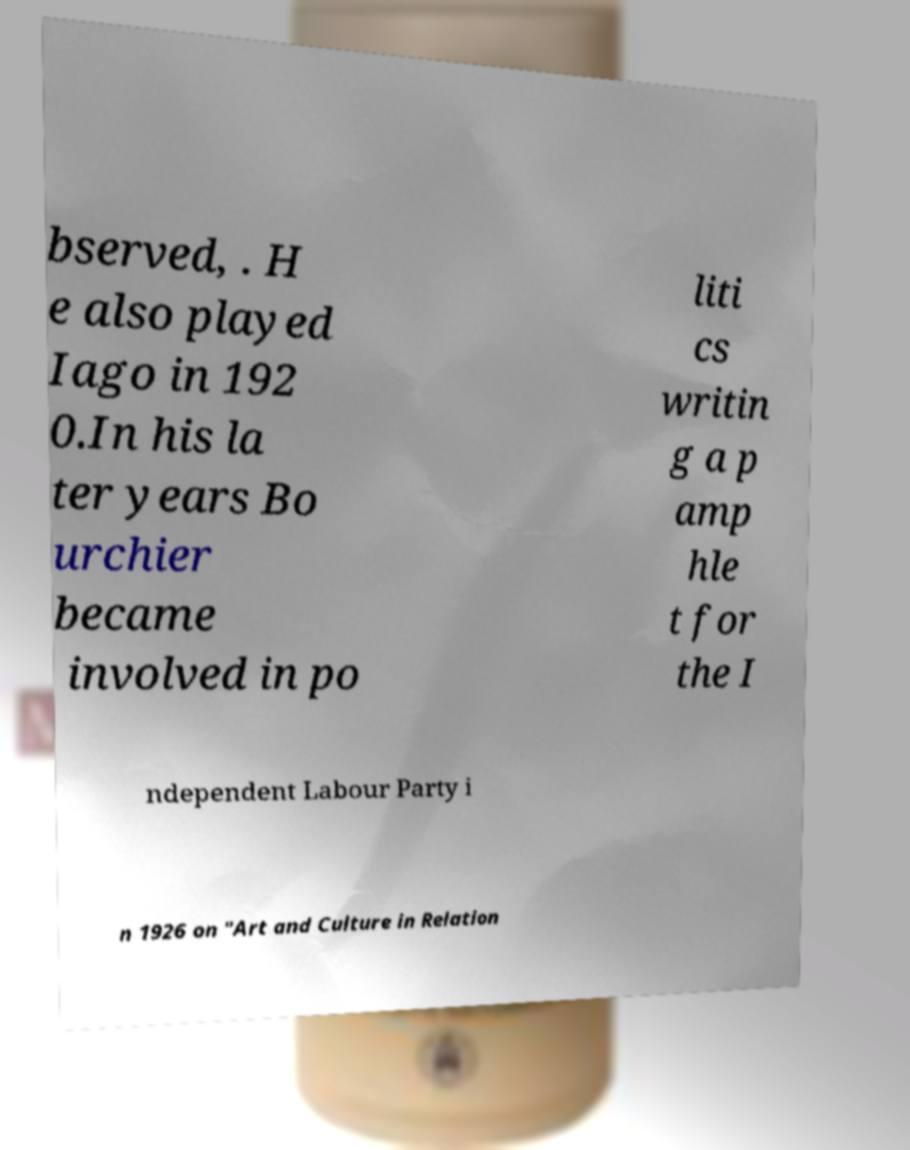Can you read and provide the text displayed in the image?This photo seems to have some interesting text. Can you extract and type it out for me? bserved, . H e also played Iago in 192 0.In his la ter years Bo urchier became involved in po liti cs writin g a p amp hle t for the I ndependent Labour Party i n 1926 on "Art and Culture in Relation 